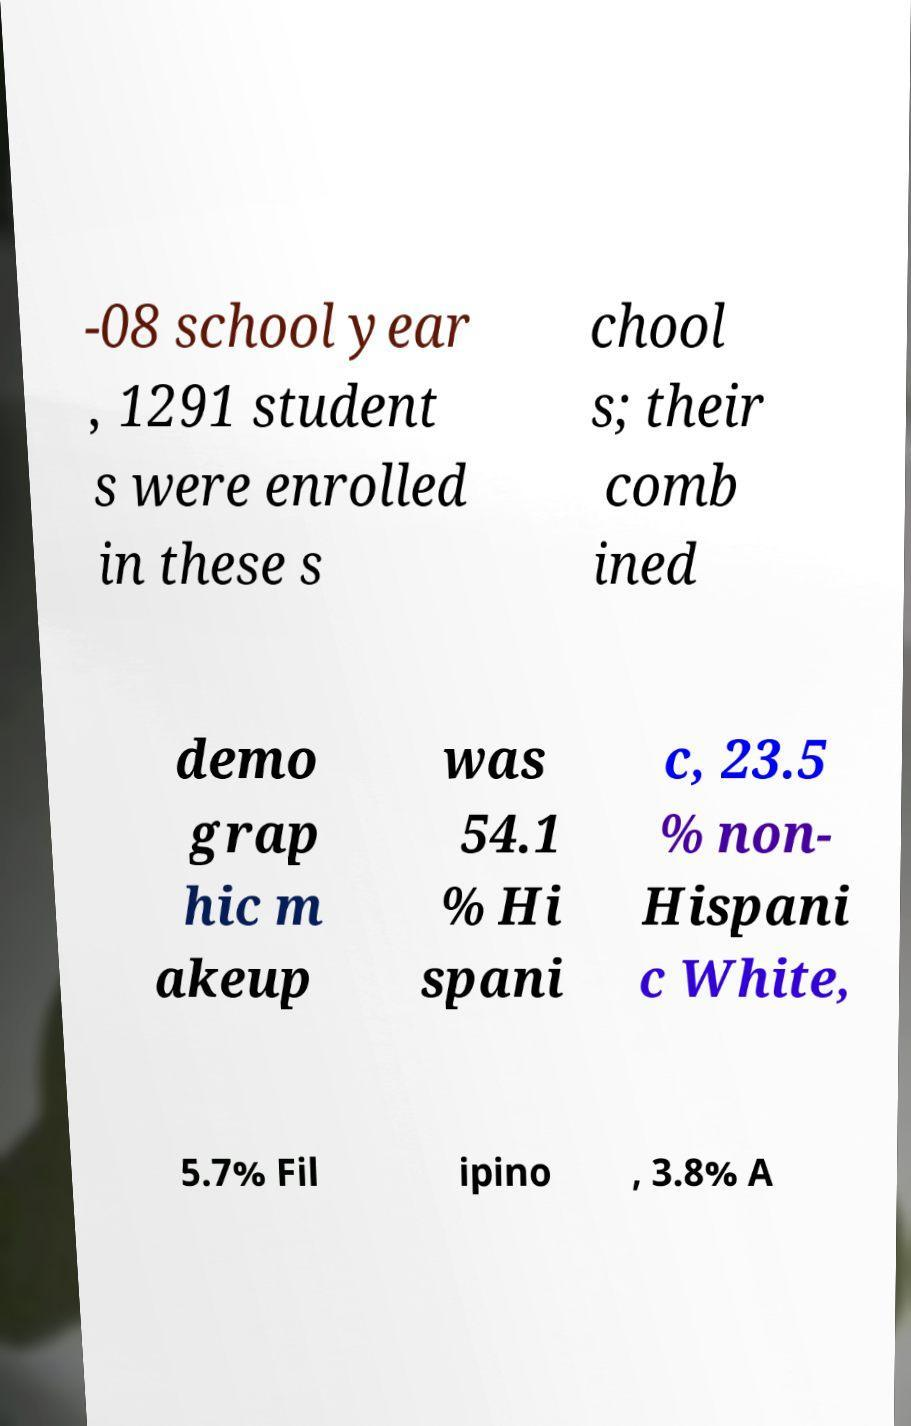What messages or text are displayed in this image? I need them in a readable, typed format. -08 school year , 1291 student s were enrolled in these s chool s; their comb ined demo grap hic m akeup was 54.1 % Hi spani c, 23.5 % non- Hispani c White, 5.7% Fil ipino , 3.8% A 